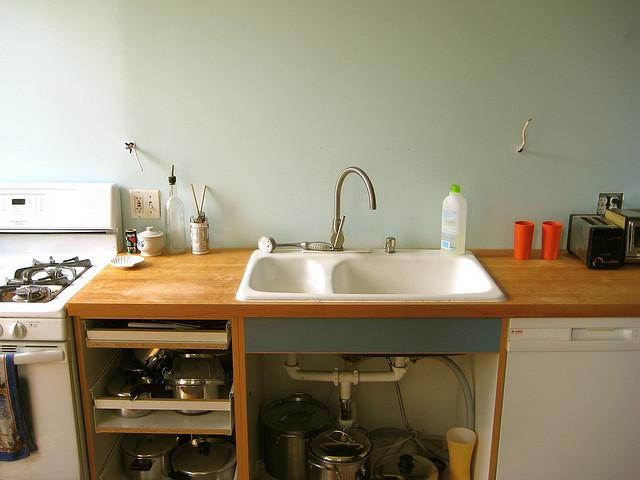What would someone most likely clean in this room? dishes 